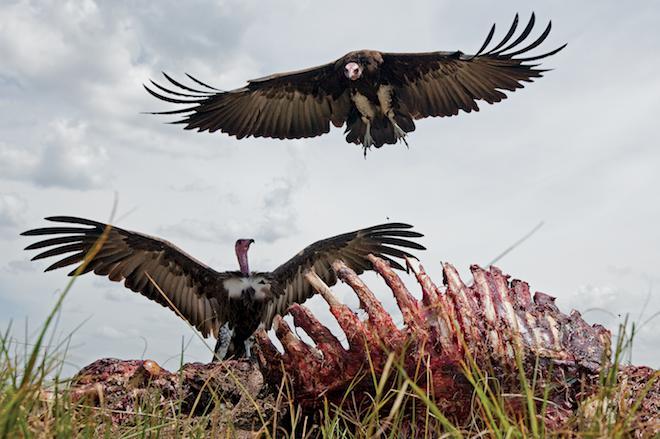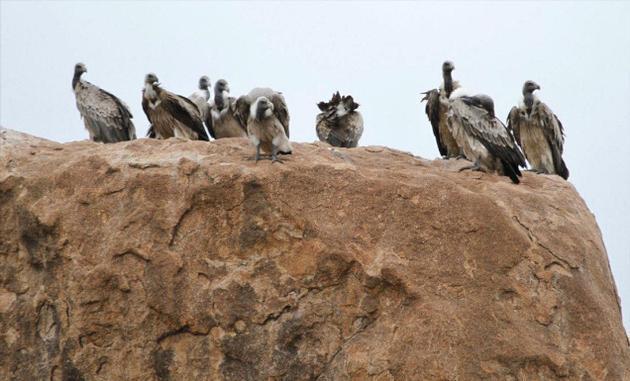The first image is the image on the left, the second image is the image on the right. For the images displayed, is the sentence "At least one of the birds has its wings spread." factually correct? Answer yes or no. Yes. 